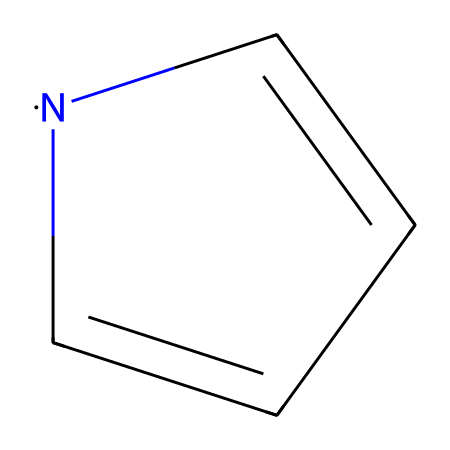What is the molecular formula of this compound? The SMILES notation can be translated into the molecular formula by counting the atoms. The compound has 5 carbon atoms, 4 hydrogen atoms, and 1 nitrogen atom, leading to the formula C5H4N.
Answer: C5H4N How many double bonds are present in this structure? The structure includes carbon atoms that are interconnected, which can be identified in the SMILES notation. There are two double bonds indicated, connecting two carbon atoms and involving the nitrogen atom.
Answer: 2 What type of compound is this? This compound fits into the category of N-heterocyclic carbenes due to the presence of a nitrogen atom in a cyclic structure, which is characteristic of this type.
Answer: N-heterocyclic carbene How does the nitrogen atom influence the stability of the carbene? The presence of nitrogen stabilizes the empty p-orbital of the carbene due to its ability to donate electron density, which can help mitigate the reactivity typically associated with carbenes.
Answer: Stabilizes What role do N-heterocyclic carbenes play in anti-corrosion coatings? N-heterocyclic carbenes can enhance the performance of anti-corrosion coatings by acting as ligands that improve the application of metal ions, thus reinforcing the coating's protective qualities.
Answer: Enhances performance What property is primarily attributed to the presence of nitrogen in this structure? The nitrogen's presence grants nucleophilicity to the carbene structure, facilitating reactivity with different substrates in chemical reactions and applications.
Answer: Nucleophilicity 